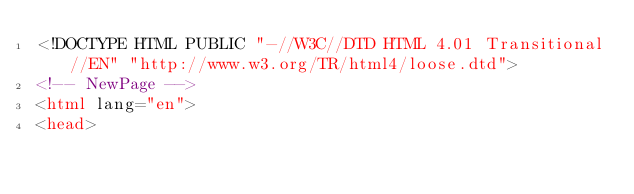<code> <loc_0><loc_0><loc_500><loc_500><_HTML_><!DOCTYPE HTML PUBLIC "-//W3C//DTD HTML 4.01 Transitional//EN" "http://www.w3.org/TR/html4/loose.dtd">
<!-- NewPage -->
<html lang="en">
<head></code> 